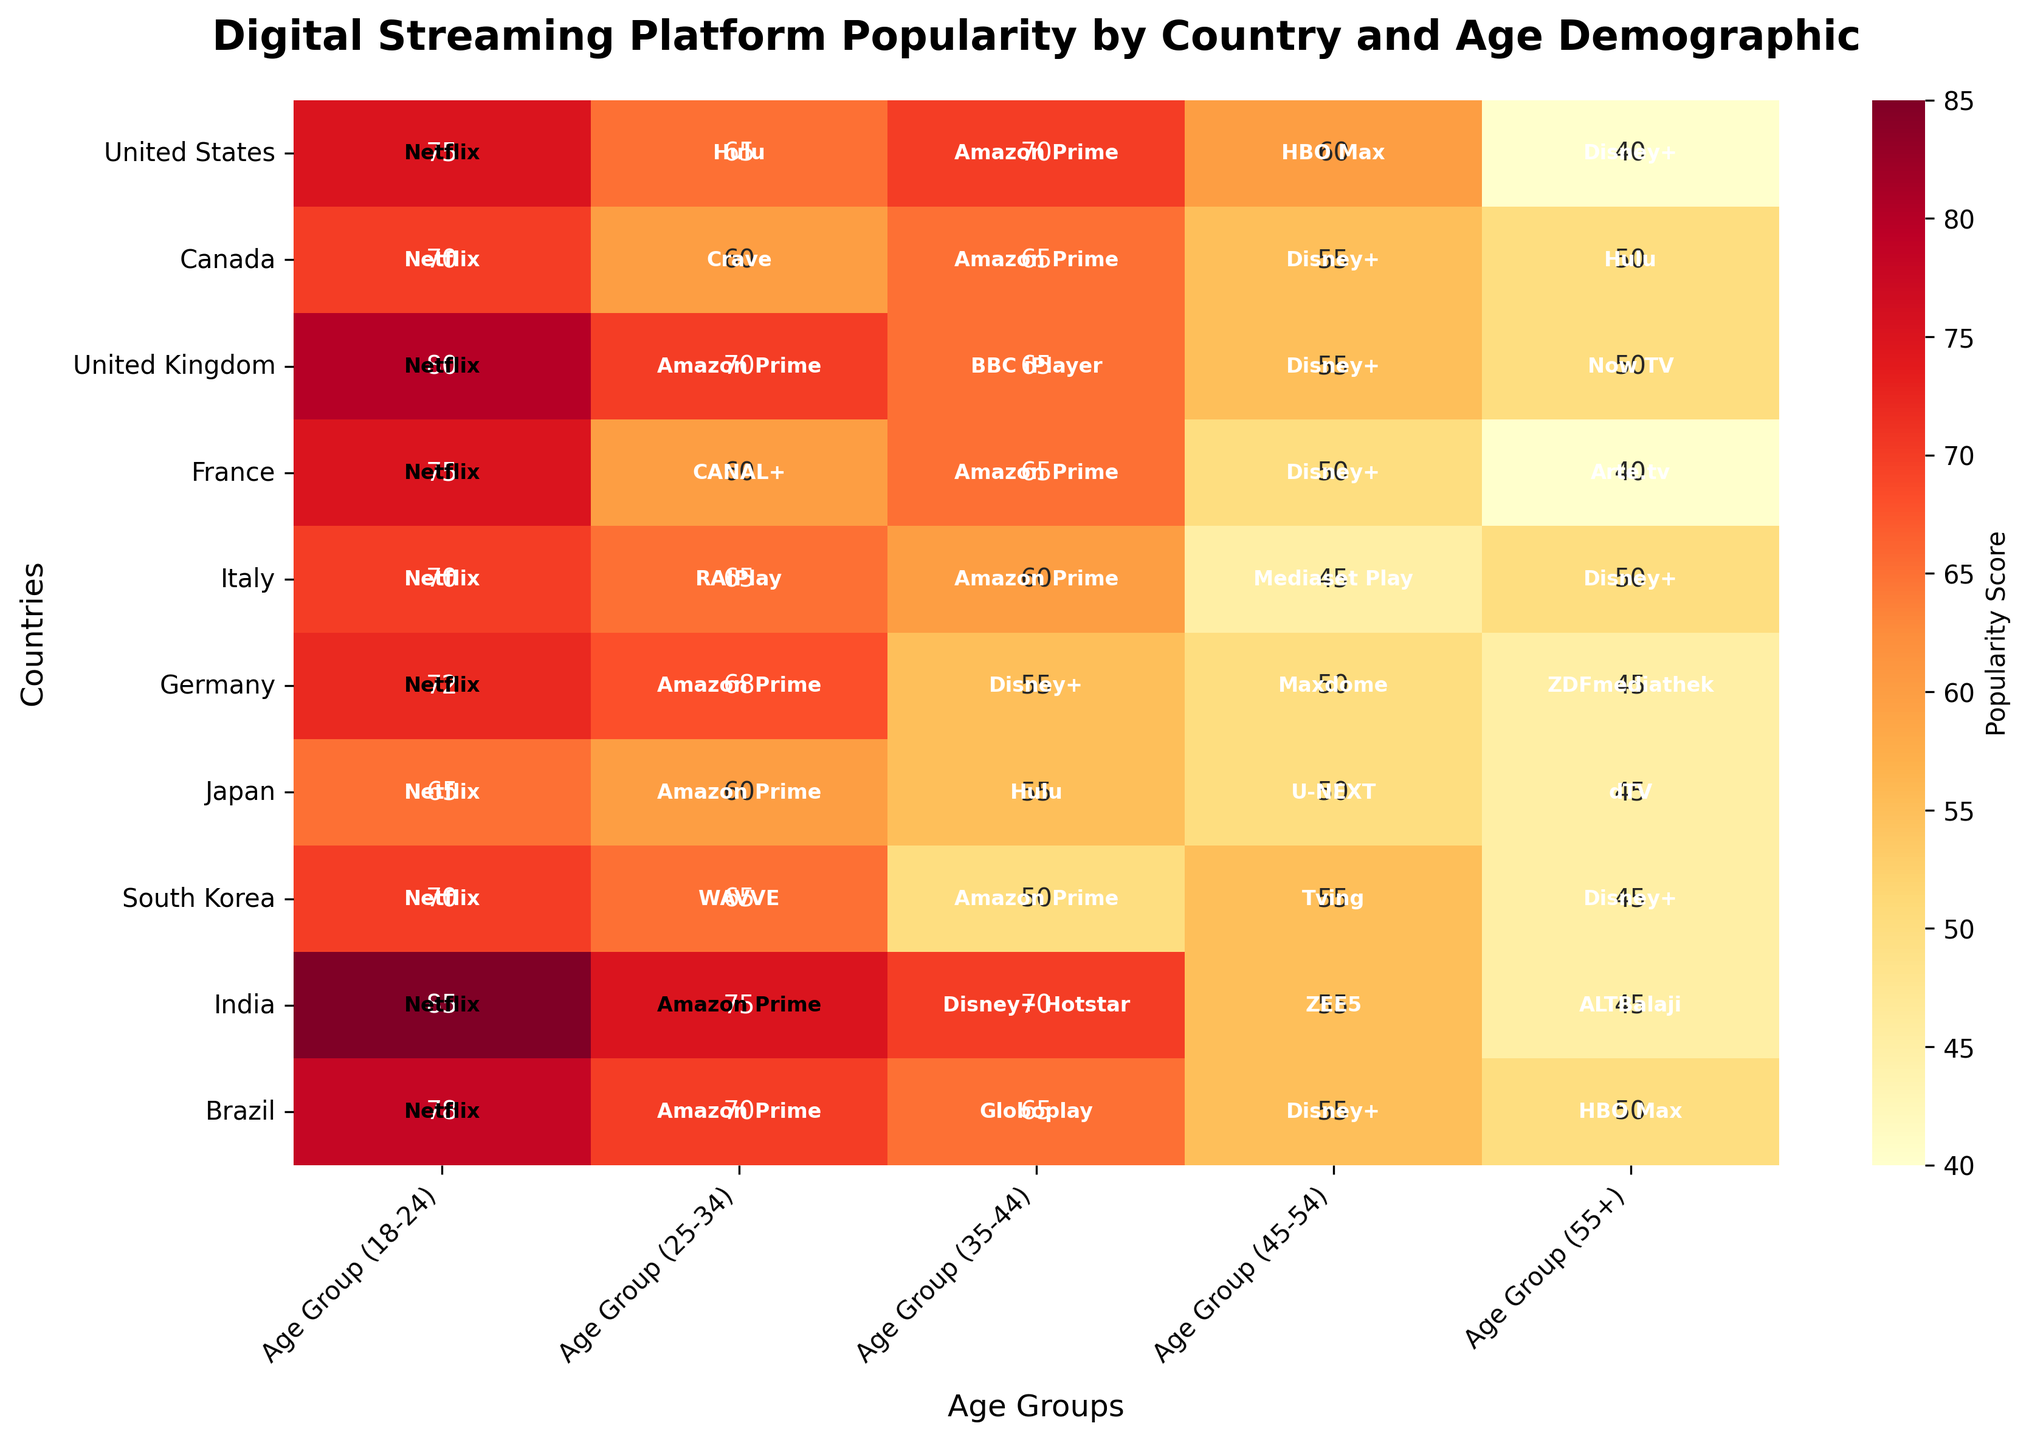Which country has the highest popularity score for Netflix among all age groups? Inspecting the heatmap, we can see the highest value under Netflix for each country and age group. The United States has the highest Netflix popularity score of 75 for the 18-24 age group.
Answer: United States In the 25-34 age group, which platform is most popular in Canada? Looking at the heatmap for the 25-34 age group in Canada, we notice the score of 60, which corresponds to Crave.
Answer: Crave What is the average popularity score of Disney+ across all countries in the 35-44 age group? To find the average score, we sum up the scores for Disney+ in the 35-44 age group: 55 (Canada) + 55 (United Kingdom) + 50 (France) + 45 (Italy) + 55 (Germany) + 55 (Brazil). The sum is 320, and there are 6 countries, so the average is 320/6.
Answer: 53.33 Which platform shows a marked preference among the 55+ demographic in Italy? From the heatmap, the highest score in the 55+ demographic for Italy is 50, which corresponds to Disney+.
Answer: Disney+ Are there any platforms that appear consistently across all age groups in a specific country? Inspect the heatmap for each country. For the United States, Netflix is present in all age groups (18-24, 25-34, 35-44, 45-54, 55+).
Answer: Yes, for the United States, Netflix How does the popularity of Amazon Prime in India for the 25-34 age group compare to the same age group in Brazil? Checking the heatmap, Amazon Prime in India for the 25-34 age group has a score of 75, whereas in Brazil it has a score of 70. Hence, Amazon Prime is more popular in India for this age group.
Answer: More popular in India Which country has the lowest popularity score for Hulu in the 18-24 age group? Only the United States and Japan list Hulu for the 18-24 age group. Comparing their scores, the lowest one is 55 in Japan.
Answer: Japan Which age group shows the greatest variety of streaming platforms across all countries? Review the number of unique platforms in each age group. The 18-24 age group shows Netflix, Hulu, Crave, BBC iPlayer, CANAL+, RAIPlay, Amazon Prime, WAVVE, Disney+ Hotstar, and Globoplay.
Answer: 18-24 What is the sum of the popularity scores of Amazon Prime for the 35-44 age group across all countries? Sum the scores for Amazon Prime in the 35-44 age group from the heatmap: 70 (United States) + 65 (Canada) + 65 (France) + 60 (Italy) + 68 (Germany) + 60 (Japan) + 50 (South Korea) + 75 (India) + 70 (Brazil). This gives a total of 583.
Answer: 583 Which platform is the least popular among the 45-54 age group in South Korea, and what is its score? Check the heatmap for the platform with the lowest score in the 45-54 age group in South Korea. The lowest score is 55 for Tving.
Answer: Tving (55) 